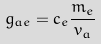Convert formula to latex. <formula><loc_0><loc_0><loc_500><loc_500>g _ { a e } = c _ { e } \frac { m _ { e } } { v _ { a } }</formula> 